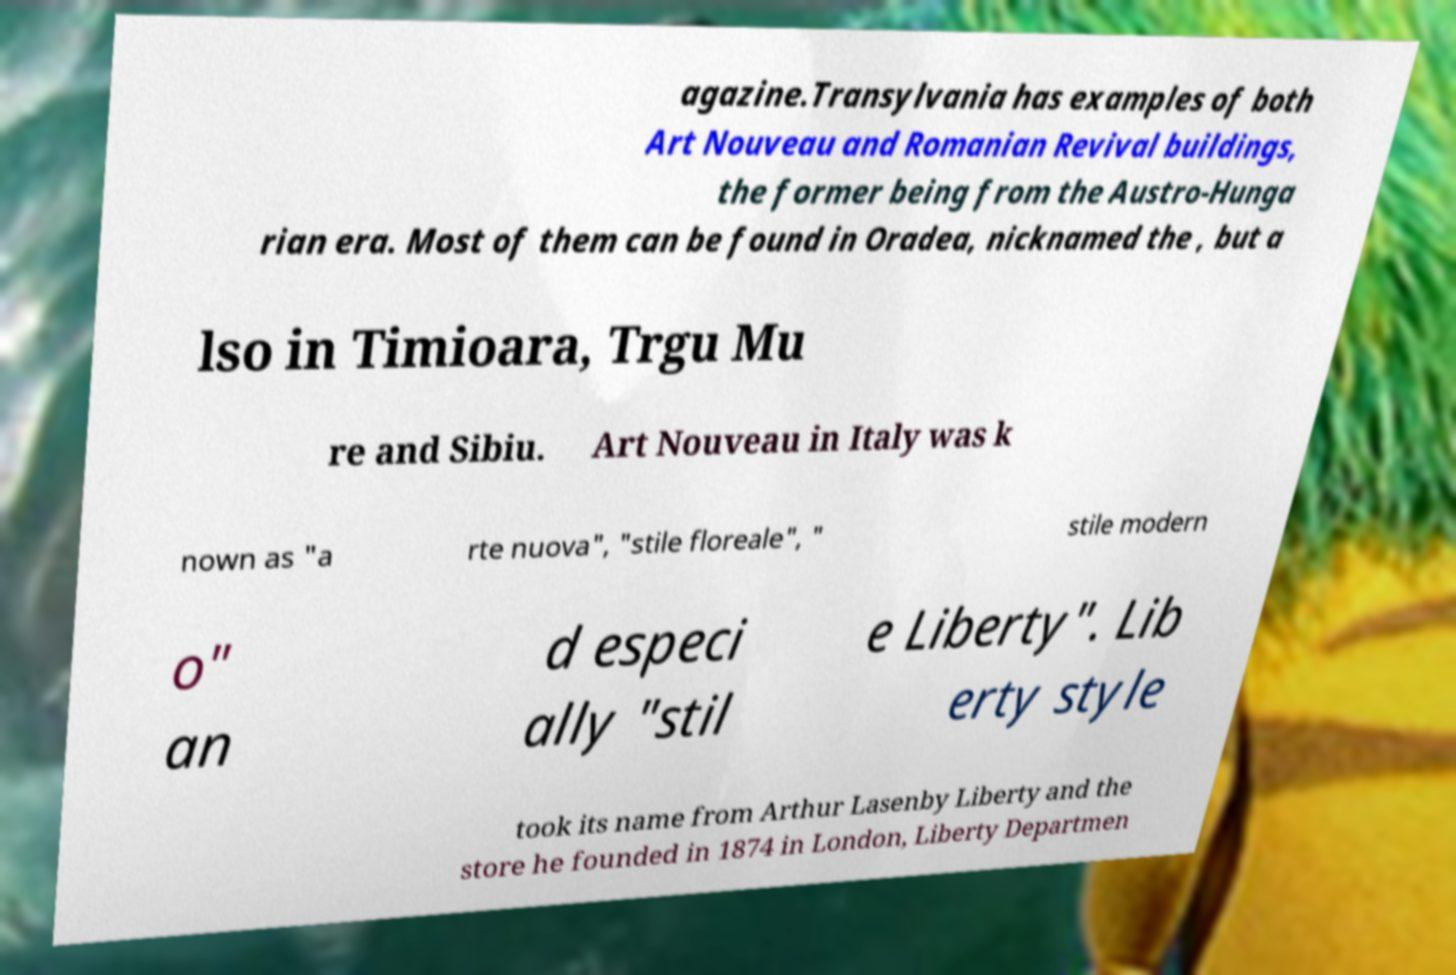Could you assist in decoding the text presented in this image and type it out clearly? agazine.Transylvania has examples of both Art Nouveau and Romanian Revival buildings, the former being from the Austro-Hunga rian era. Most of them can be found in Oradea, nicknamed the , but a lso in Timioara, Trgu Mu re and Sibiu. Art Nouveau in Italy was k nown as "a rte nuova", "stile floreale", " stile modern o" an d especi ally "stil e Liberty". Lib erty style took its name from Arthur Lasenby Liberty and the store he founded in 1874 in London, Liberty Departmen 